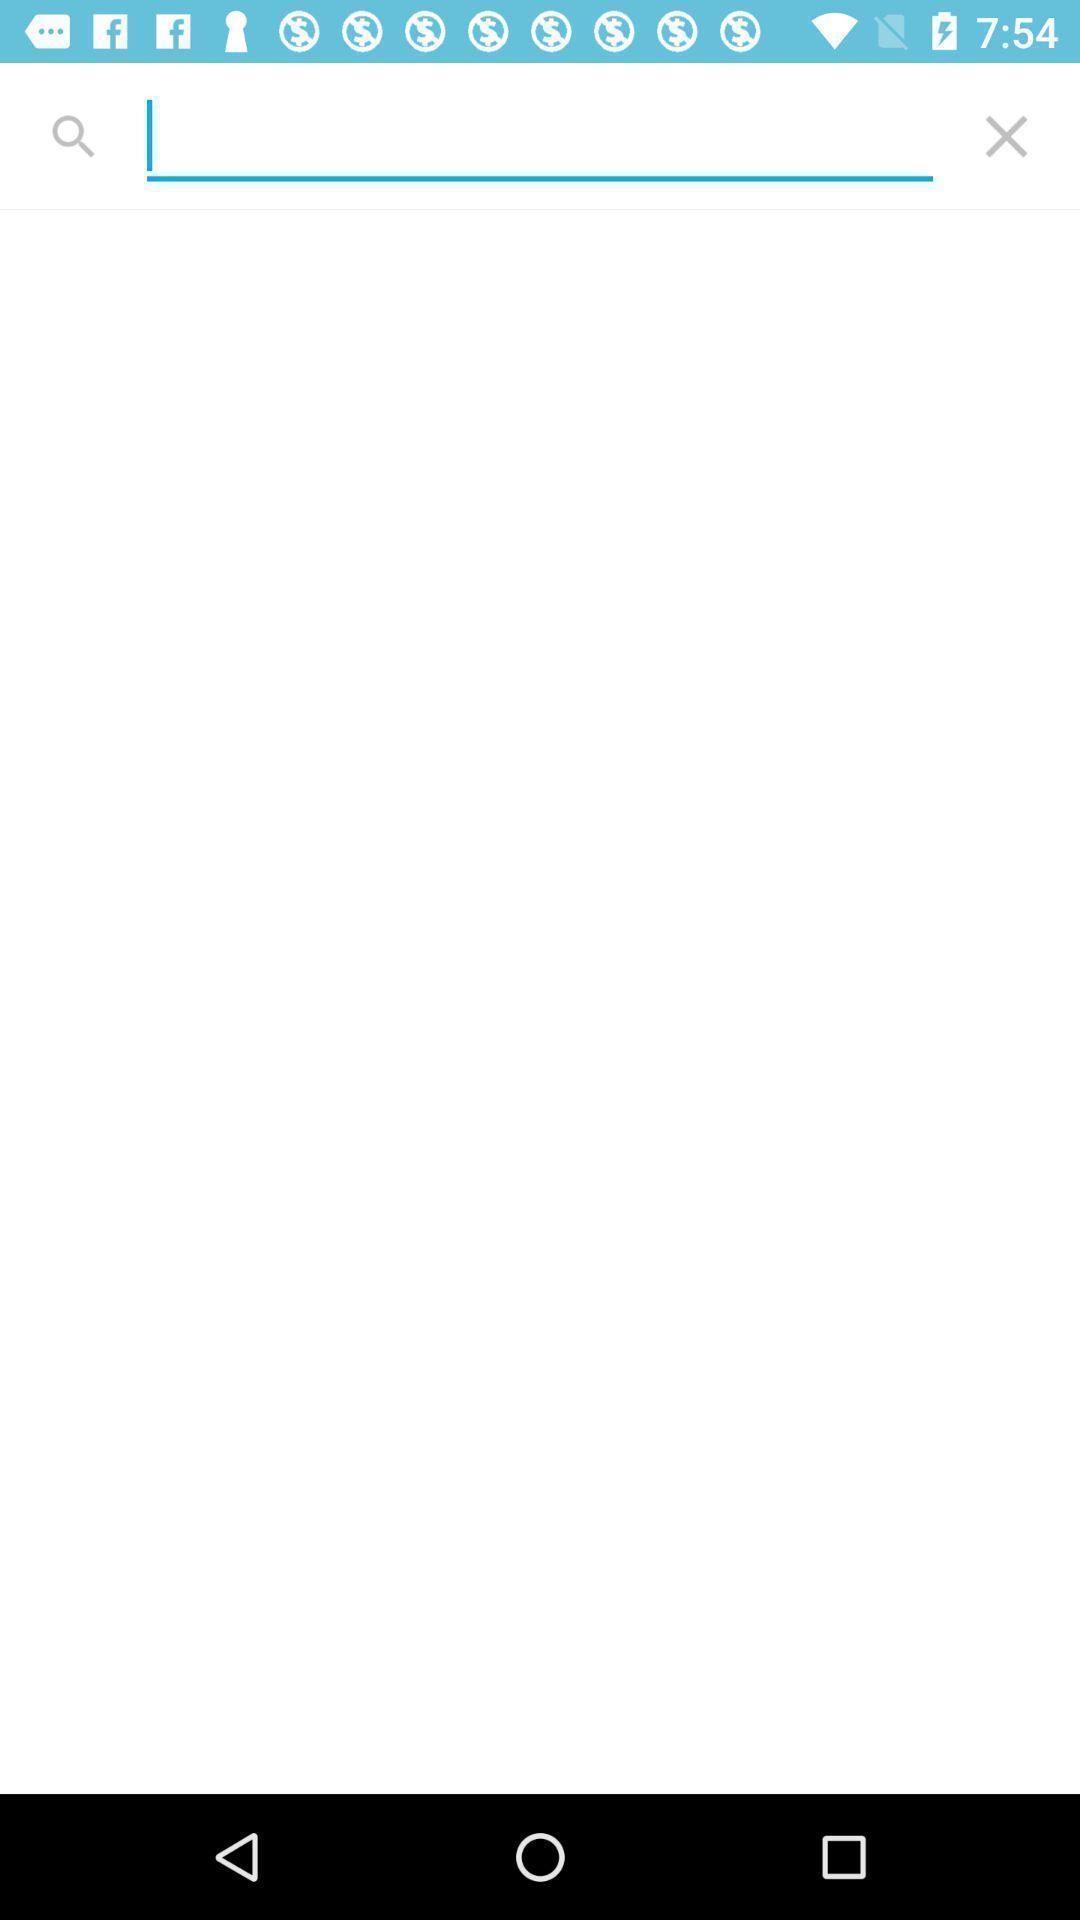Explain the elements present in this screenshot. Screen displaying the search bar. 